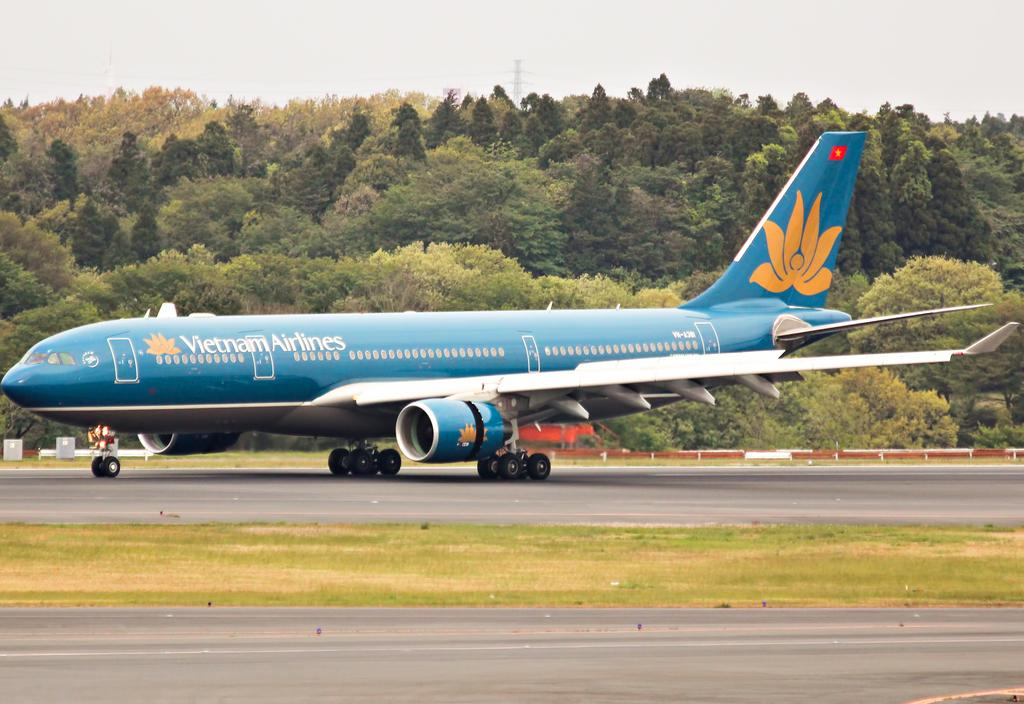<image>
Present a compact description of the photo's key features. A Vietnam Airlines plane sits on the runway. 